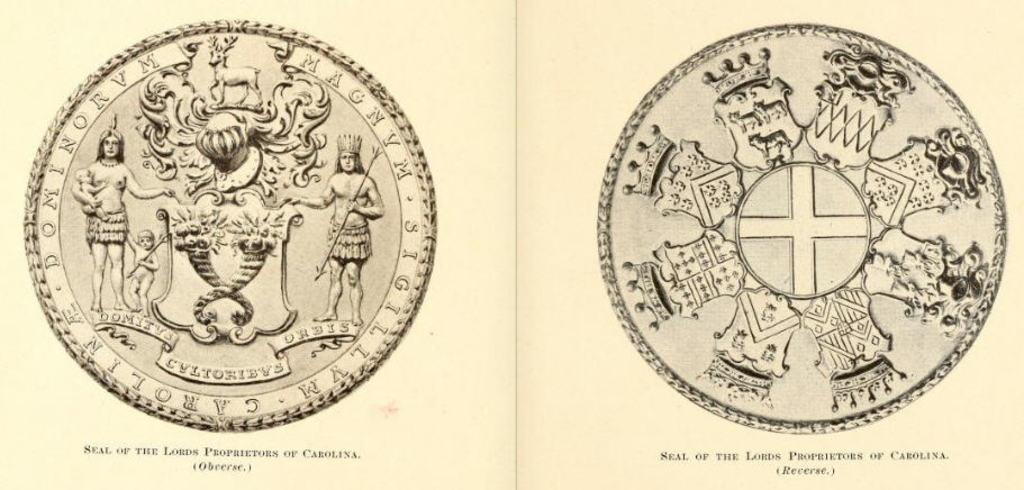<image>
Provide a brief description of the given image. The front and back of a coin with the text "Neal of the Lords Proprietors of Carolina" 